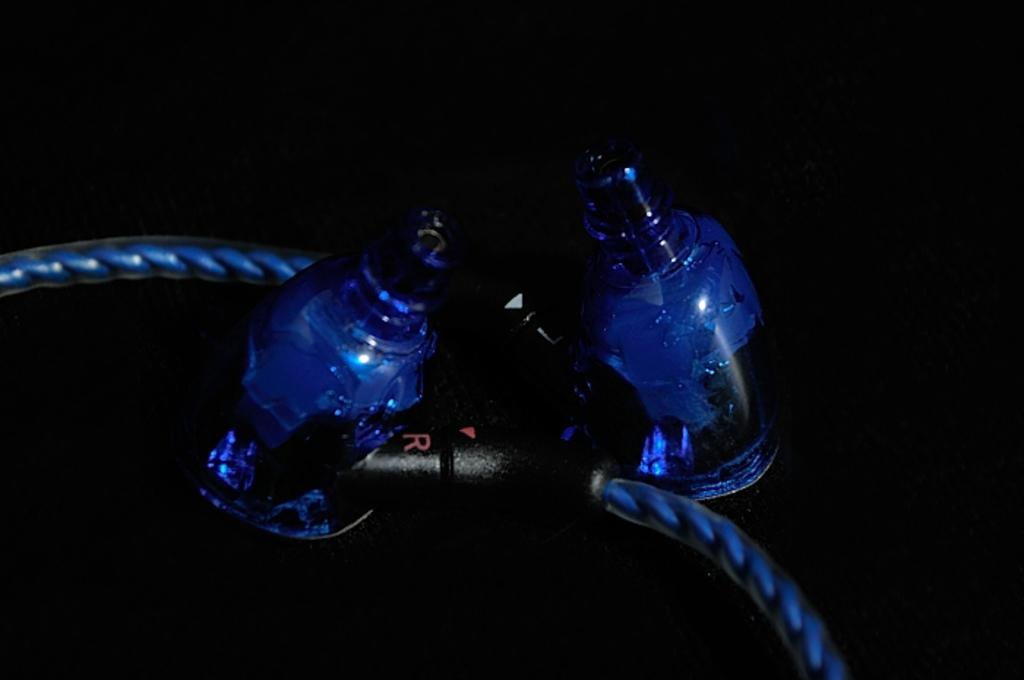<image>
Describe the image concisely. the letter R that is on a black item 